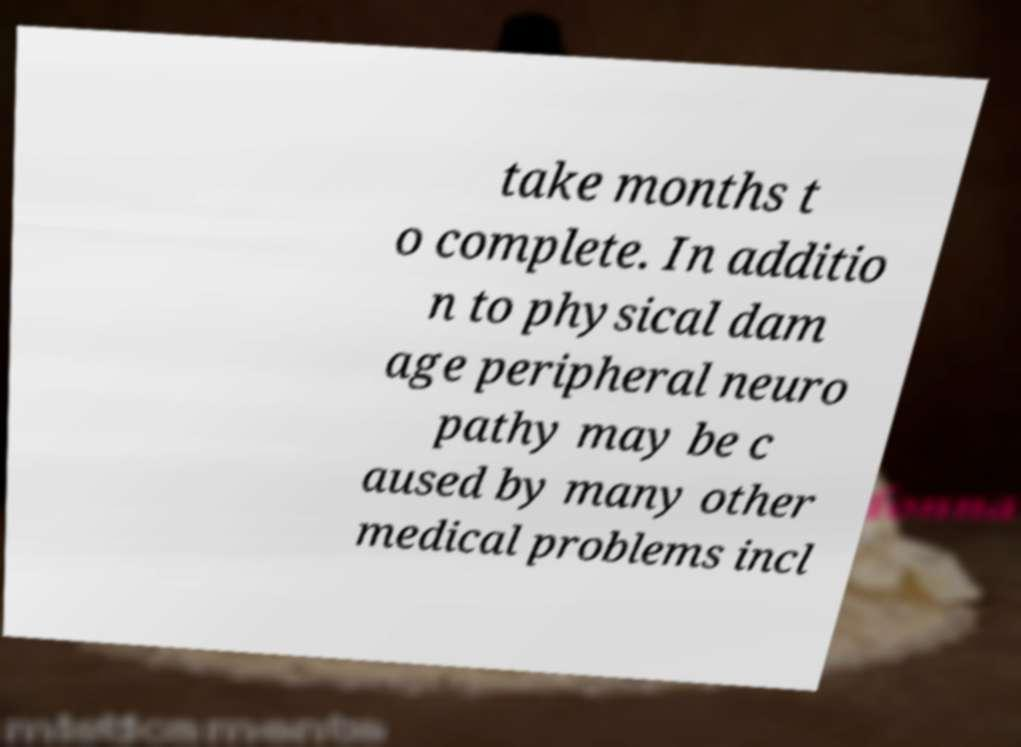Can you accurately transcribe the text from the provided image for me? take months t o complete. In additio n to physical dam age peripheral neuro pathy may be c aused by many other medical problems incl 